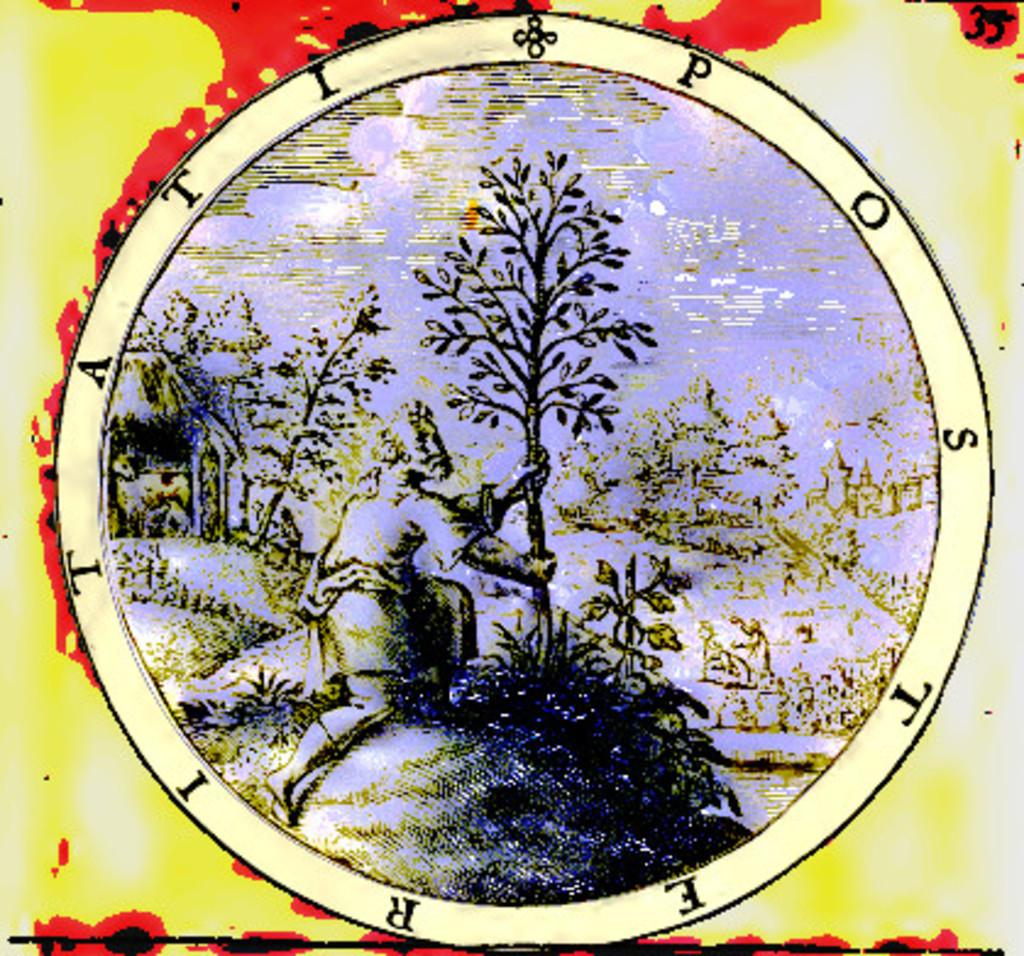What can be observed about the image's appearance? The image is edited. What shape is present in the image? There is a circle in the image. What is the man in the image doing? The man is holding a tree in the image. How many times has the plate been folded in the image? There is no plate present in the image, so it cannot be folded. Can you describe the ladybug's color in the image? There is no ladybug present in the image. 